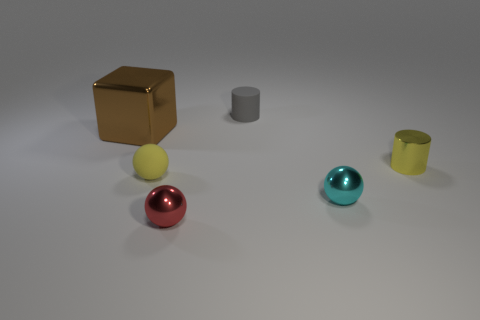How many tiny things are gray matte cylinders or red rubber cylinders?
Give a very brief answer. 1. What number of tiny yellow balls are on the right side of the gray matte cylinder?
Ensure brevity in your answer.  0. The other metal object that is the same shape as the tiny red metallic object is what color?
Your answer should be compact. Cyan. What number of rubber objects are either gray balls or red things?
Provide a succinct answer. 0. There is a cylinder that is in front of the thing that is behind the large brown shiny object; is there a brown cube that is on the right side of it?
Your answer should be very brief. No. What color is the tiny metal cylinder?
Keep it short and to the point. Yellow. There is a yellow object that is to the right of the yellow sphere; does it have the same shape as the gray matte thing?
Provide a succinct answer. Yes. How many objects are cyan balls or things that are in front of the cyan shiny ball?
Ensure brevity in your answer.  2. Are the small cylinder behind the brown cube and the tiny red ball made of the same material?
Provide a short and direct response. No. Are there any other things that are the same size as the cube?
Ensure brevity in your answer.  No. 